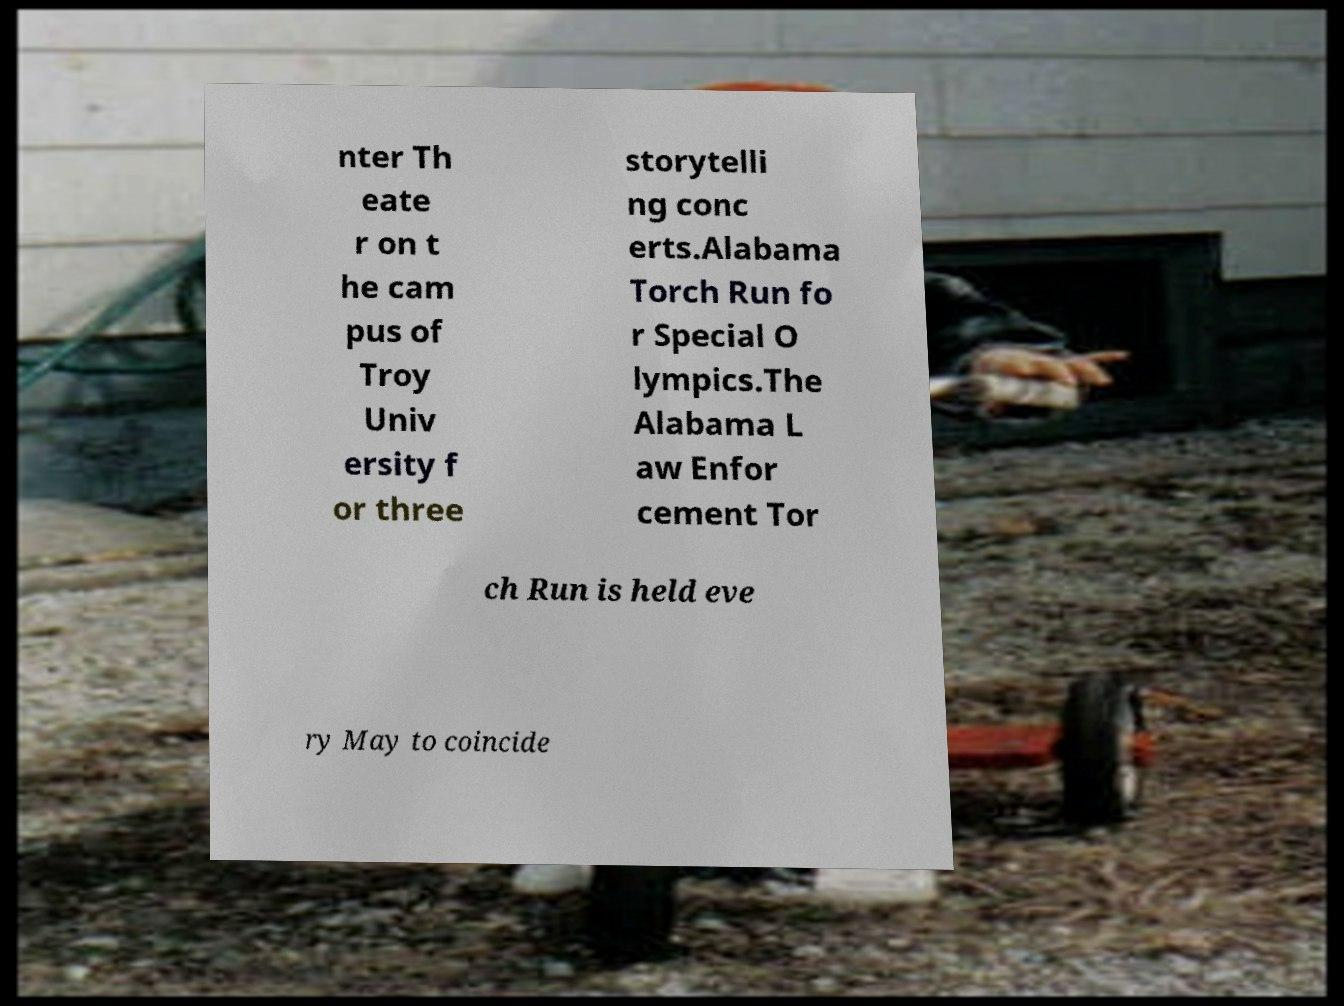I need the written content from this picture converted into text. Can you do that? nter Th eate r on t he cam pus of Troy Univ ersity f or three storytelli ng conc erts.Alabama Torch Run fo r Special O lympics.The Alabama L aw Enfor cement Tor ch Run is held eve ry May to coincide 